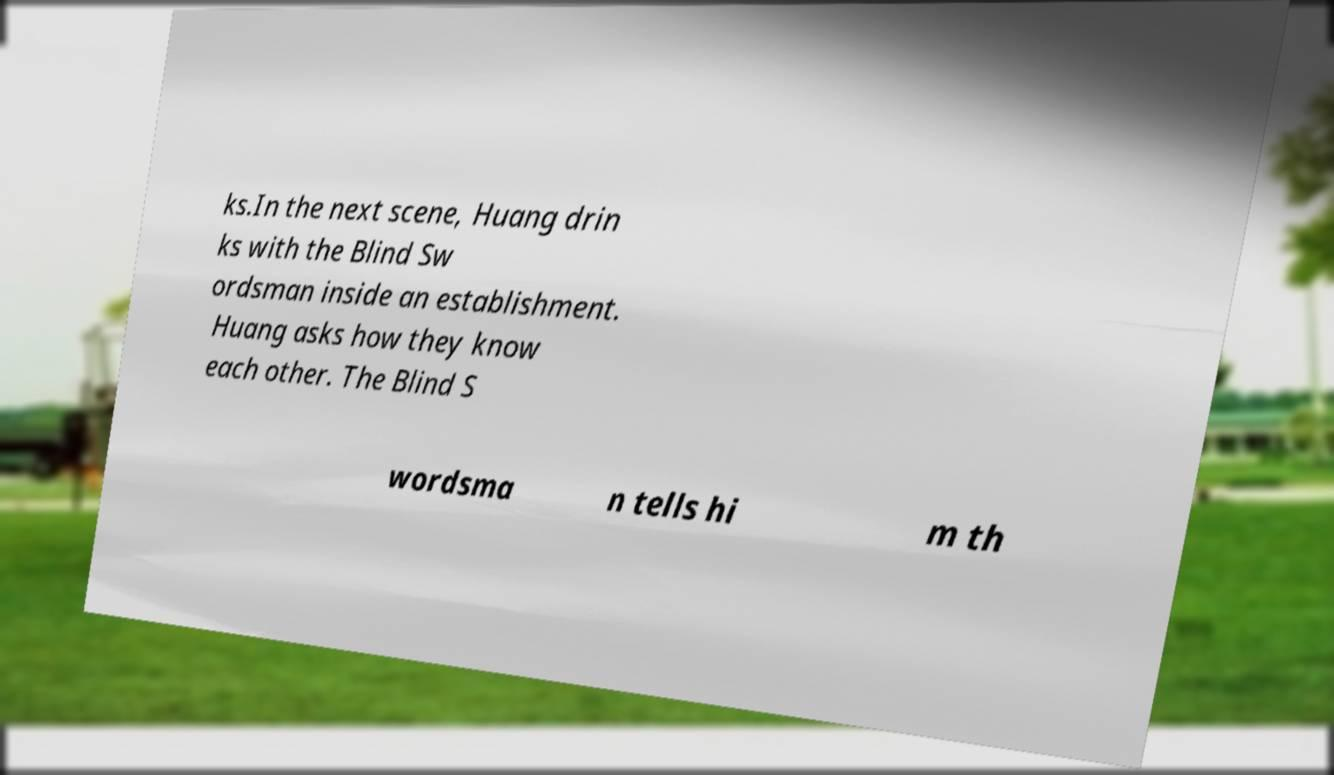There's text embedded in this image that I need extracted. Can you transcribe it verbatim? ks.In the next scene, Huang drin ks with the Blind Sw ordsman inside an establishment. Huang asks how they know each other. The Blind S wordsma n tells hi m th 